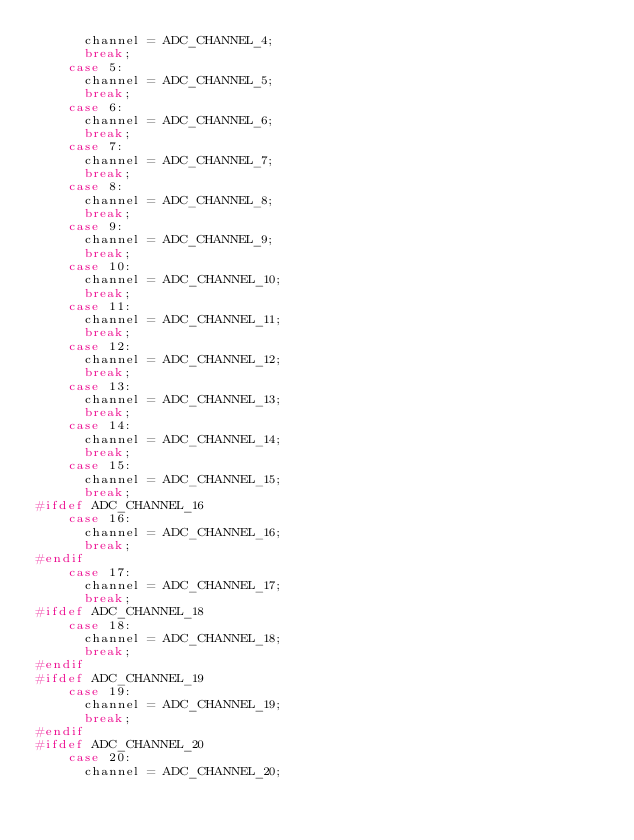Convert code to text. <code><loc_0><loc_0><loc_500><loc_500><_C++_>      channel = ADC_CHANNEL_4;
      break;
    case 5:
      channel = ADC_CHANNEL_5;
      break;
    case 6:
      channel = ADC_CHANNEL_6;
      break;
    case 7:
      channel = ADC_CHANNEL_7;
      break;
    case 8:
      channel = ADC_CHANNEL_8;
      break;
    case 9:
      channel = ADC_CHANNEL_9;
      break;
    case 10:
      channel = ADC_CHANNEL_10;
      break;
    case 11:
      channel = ADC_CHANNEL_11;
      break;
    case 12:
      channel = ADC_CHANNEL_12;
      break;
    case 13:
      channel = ADC_CHANNEL_13;
      break;
    case 14:
      channel = ADC_CHANNEL_14;
      break;
    case 15:
      channel = ADC_CHANNEL_15;
      break;
#ifdef ADC_CHANNEL_16
    case 16:
      channel = ADC_CHANNEL_16;
      break;
#endif
    case 17:
      channel = ADC_CHANNEL_17;
      break;
#ifdef ADC_CHANNEL_18
    case 18:
      channel = ADC_CHANNEL_18;
      break;
#endif
#ifdef ADC_CHANNEL_19
    case 19:
      channel = ADC_CHANNEL_19;
      break;
#endif
#ifdef ADC_CHANNEL_20
    case 20:
      channel = ADC_CHANNEL_20;</code> 